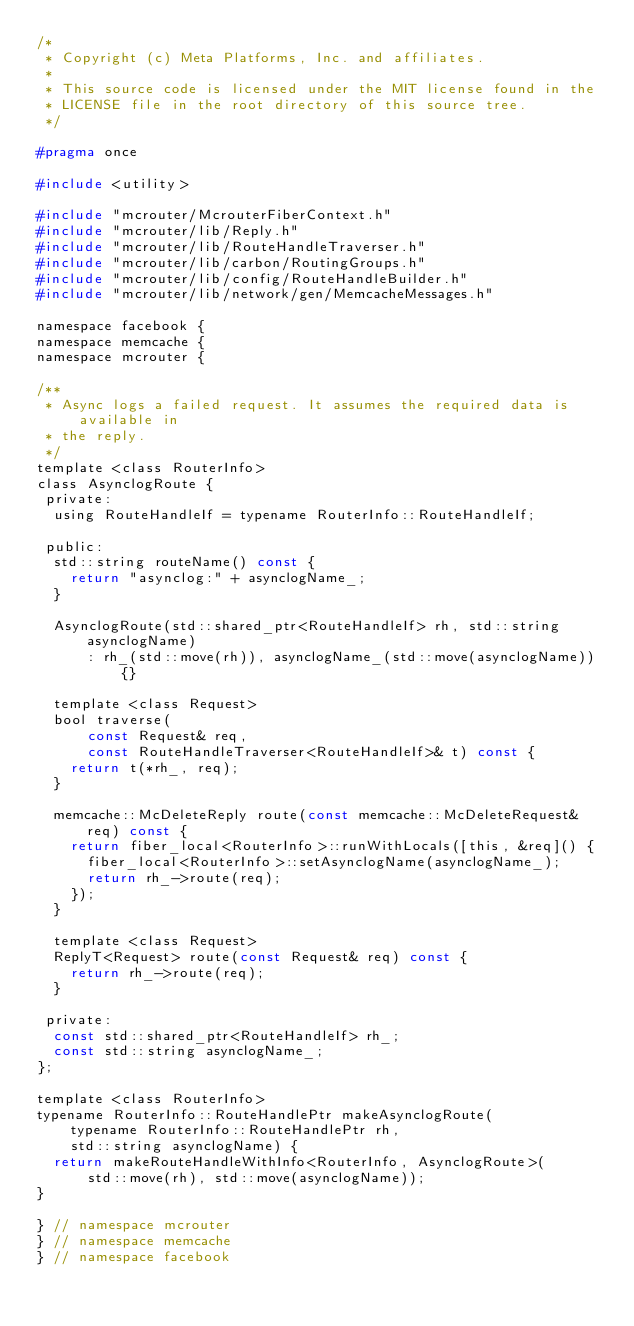<code> <loc_0><loc_0><loc_500><loc_500><_C_>/*
 * Copyright (c) Meta Platforms, Inc. and affiliates.
 *
 * This source code is licensed under the MIT license found in the
 * LICENSE file in the root directory of this source tree.
 */

#pragma once

#include <utility>

#include "mcrouter/McrouterFiberContext.h"
#include "mcrouter/lib/Reply.h"
#include "mcrouter/lib/RouteHandleTraverser.h"
#include "mcrouter/lib/carbon/RoutingGroups.h"
#include "mcrouter/lib/config/RouteHandleBuilder.h"
#include "mcrouter/lib/network/gen/MemcacheMessages.h"

namespace facebook {
namespace memcache {
namespace mcrouter {

/**
 * Async logs a failed request. It assumes the required data is available in
 * the reply.
 */
template <class RouterInfo>
class AsynclogRoute {
 private:
  using RouteHandleIf = typename RouterInfo::RouteHandleIf;

 public:
  std::string routeName() const {
    return "asynclog:" + asynclogName_;
  }

  AsynclogRoute(std::shared_ptr<RouteHandleIf> rh, std::string asynclogName)
      : rh_(std::move(rh)), asynclogName_(std::move(asynclogName)) {}

  template <class Request>
  bool traverse(
      const Request& req,
      const RouteHandleTraverser<RouteHandleIf>& t) const {
    return t(*rh_, req);
  }

  memcache::McDeleteReply route(const memcache::McDeleteRequest& req) const {
    return fiber_local<RouterInfo>::runWithLocals([this, &req]() {
      fiber_local<RouterInfo>::setAsynclogName(asynclogName_);
      return rh_->route(req);
    });
  }

  template <class Request>
  ReplyT<Request> route(const Request& req) const {
    return rh_->route(req);
  }

 private:
  const std::shared_ptr<RouteHandleIf> rh_;
  const std::string asynclogName_;
};

template <class RouterInfo>
typename RouterInfo::RouteHandlePtr makeAsynclogRoute(
    typename RouterInfo::RouteHandlePtr rh,
    std::string asynclogName) {
  return makeRouteHandleWithInfo<RouterInfo, AsynclogRoute>(
      std::move(rh), std::move(asynclogName));
}

} // namespace mcrouter
} // namespace memcache
} // namespace facebook
</code> 